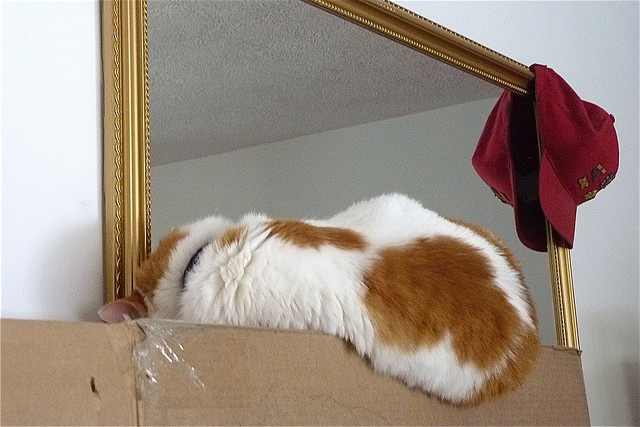Describe the objects in this image and their specific colors. I can see a cat in white, lightgray, darkgray, and maroon tones in this image. 